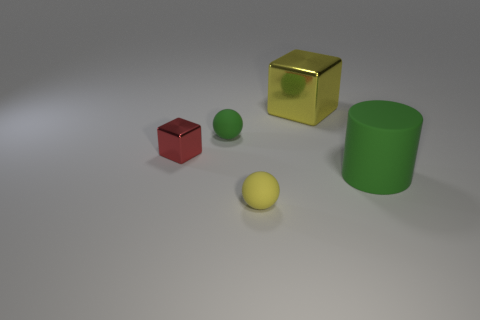There is a object that is both behind the tiny block and in front of the yellow shiny cube; what shape is it?
Give a very brief answer. Sphere. Is there a rubber thing of the same color as the large cube?
Your response must be concise. Yes. There is a shiny cube left of the small object that is right of the small green thing; what is its color?
Your answer should be compact. Red. There is a object that is on the left side of the green object that is to the left of the rubber thing to the right of the yellow ball; what is its size?
Ensure brevity in your answer.  Small. Does the big block have the same material as the small object that is behind the small metal object?
Your answer should be very brief. No. What size is the green thing that is the same material as the big green cylinder?
Your response must be concise. Small. Are there any big shiny things that have the same shape as the tiny red shiny object?
Provide a short and direct response. Yes. How many things are either cubes that are on the left side of the green rubber cylinder or small blue cubes?
Offer a terse response. 2. Do the ball that is on the left side of the yellow rubber object and the matte thing that is on the right side of the yellow sphere have the same color?
Offer a very short reply. Yes. What is the size of the green matte cylinder?
Your answer should be very brief. Large. 